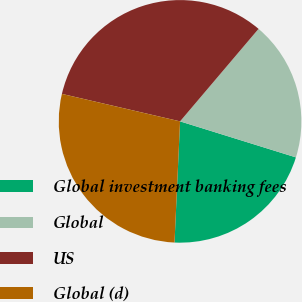Convert chart. <chart><loc_0><loc_0><loc_500><loc_500><pie_chart><fcel>Global investment banking fees<fcel>Global<fcel>US<fcel>Global (d)<nl><fcel>20.93%<fcel>18.6%<fcel>32.56%<fcel>27.91%<nl></chart> 